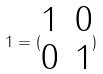Convert formula to latex. <formula><loc_0><loc_0><loc_500><loc_500>1 = ( \begin{matrix} 1 & 0 \\ 0 & 1 \end{matrix} )</formula> 